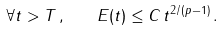<formula> <loc_0><loc_0><loc_500><loc_500>\forall t > T \, , \quad E ( t ) \leq C \, t ^ { 2 / ( p - 1 ) } \, .</formula> 